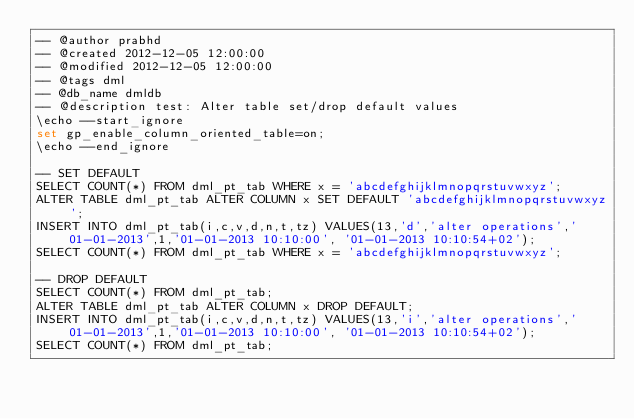<code> <loc_0><loc_0><loc_500><loc_500><_SQL_>-- @author prabhd
-- @created 2012-12-05 12:00:00
-- @modified 2012-12-05 12:00:00
-- @tags dml
-- @db_name dmldb
-- @description test: Alter table set/drop default values
\echo --start_ignore
set gp_enable_column_oriented_table=on;
\echo --end_ignore

-- SET DEFAULT
SELECT COUNT(*) FROM dml_pt_tab WHERE x = 'abcdefghijklmnopqrstuvwxyz';
ALTER TABLE dml_pt_tab ALTER COLUMN x SET DEFAULT 'abcdefghijklmnopqrstuvwxyz';
INSERT INTO dml_pt_tab(i,c,v,d,n,t,tz) VALUES(13,'d','alter operations','01-01-2013',1,'01-01-2013 10:10:00', '01-01-2013 10:10:54+02');
SELECT COUNT(*) FROM dml_pt_tab WHERE x = 'abcdefghijklmnopqrstuvwxyz';

-- DROP DEFAULT
SELECT COUNT(*) FROM dml_pt_tab;
ALTER TABLE dml_pt_tab ALTER COLUMN x DROP DEFAULT;
INSERT INTO dml_pt_tab(i,c,v,d,n,t,tz) VALUES(13,'i','alter operations','01-01-2013',1,'01-01-2013 10:10:00', '01-01-2013 10:10:54+02');
SELECT COUNT(*) FROM dml_pt_tab;


</code> 